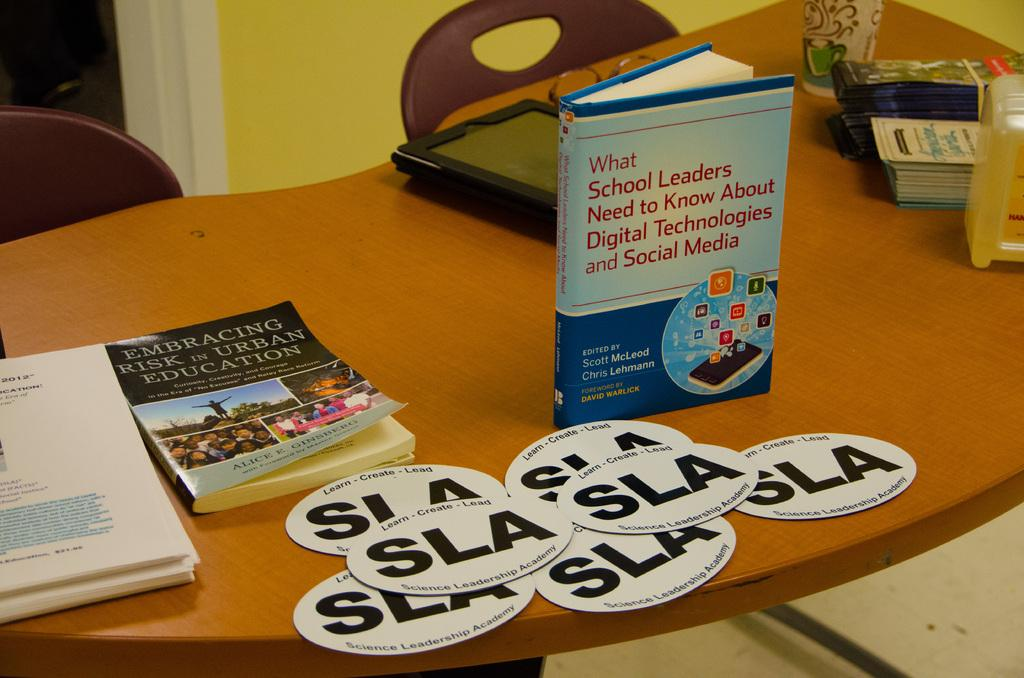What type of objects can be seen in the image? The image contains books, a gadget, and a glass on the table. Can you describe the pages visible in the image? Yes, there are pages visible in the image, which suggests that the books are open. What accessory is present in the image? Spectacles are present in the image. What type of furniture is visible in the image? Chairs are visible in the image. What is the background of the image? There is a wall in the image. What type of club can be seen in the image? There is no club present in the image; it contains books, a gadget, and a glass on the table. What is the common interest of the people in the image? There is no indication of people or their interests in the image; it only shows books, a gadget, and a glass on the table. 